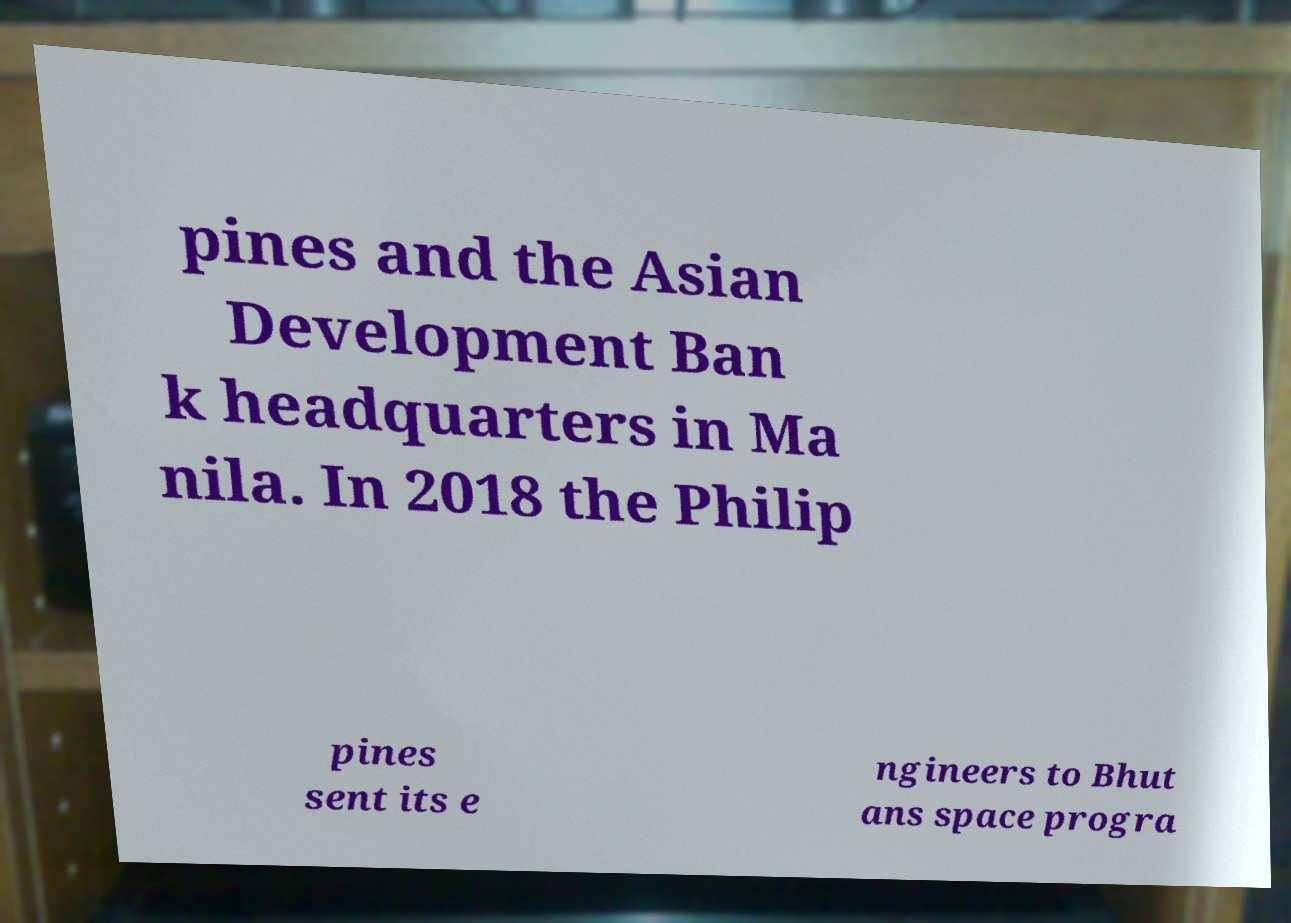Please read and relay the text visible in this image. What does it say? pines and the Asian Development Ban k headquarters in Ma nila. In 2018 the Philip pines sent its e ngineers to Bhut ans space progra 